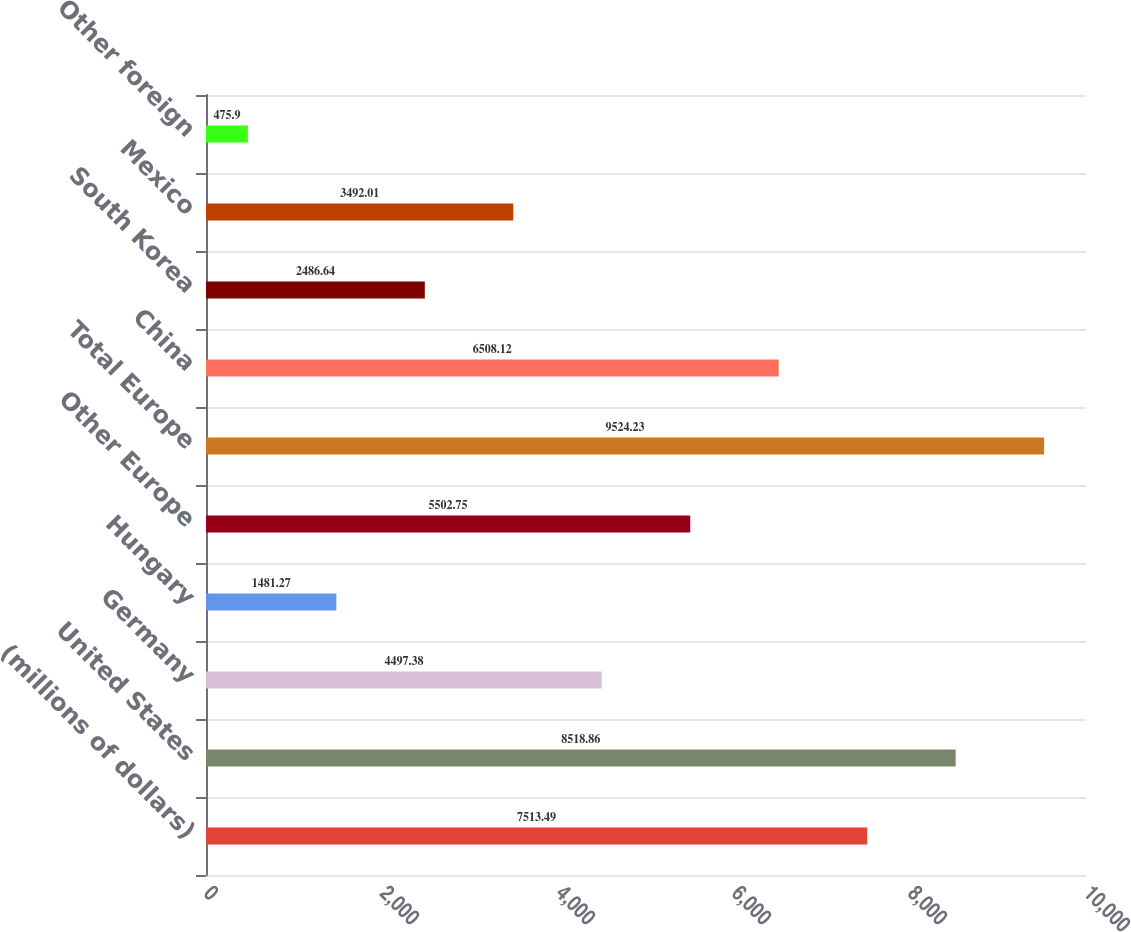Convert chart to OTSL. <chart><loc_0><loc_0><loc_500><loc_500><bar_chart><fcel>(millions of dollars)<fcel>United States<fcel>Germany<fcel>Hungary<fcel>Other Europe<fcel>Total Europe<fcel>China<fcel>South Korea<fcel>Mexico<fcel>Other foreign<nl><fcel>7513.49<fcel>8518.86<fcel>4497.38<fcel>1481.27<fcel>5502.75<fcel>9524.23<fcel>6508.12<fcel>2486.64<fcel>3492.01<fcel>475.9<nl></chart> 